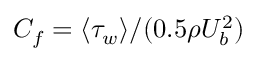Convert formula to latex. <formula><loc_0><loc_0><loc_500><loc_500>C _ { f } = \langle \tau _ { w } \rangle / ( 0 . 5 \rho U _ { b } ^ { 2 } )</formula> 